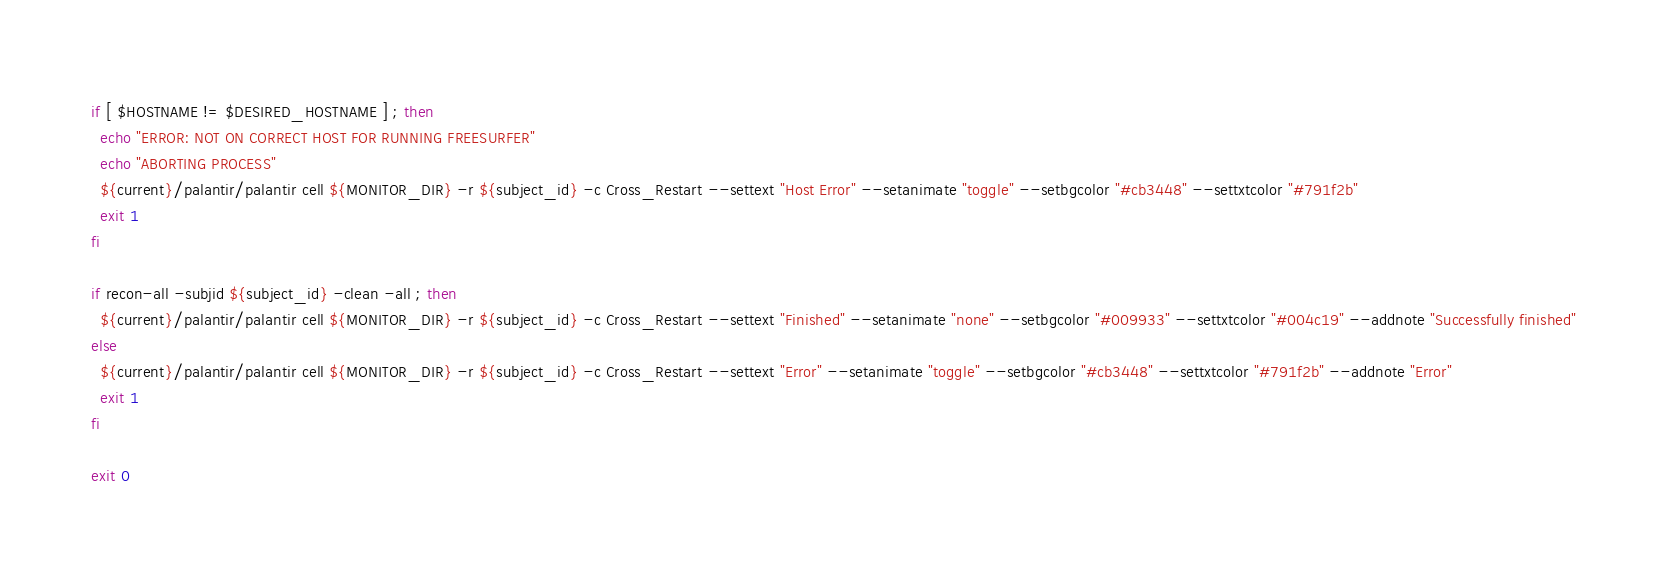<code> <loc_0><loc_0><loc_500><loc_500><_Bash_>
if [ $HOSTNAME != $DESIRED_HOSTNAME ] ; then
  echo "ERROR: NOT ON CORRECT HOST FOR RUNNING FREESURFER"
  echo "ABORTING PROCESS"
  ${current}/palantir/palantir cell ${MONITOR_DIR} -r ${subject_id} -c Cross_Restart --settext "Host Error" --setanimate "toggle" --setbgcolor "#cb3448" --settxtcolor "#791f2b"
  exit 1
fi

if recon-all -subjid ${subject_id} -clean -all ; then
  ${current}/palantir/palantir cell ${MONITOR_DIR} -r ${subject_id} -c Cross_Restart --settext "Finished" --setanimate "none" --setbgcolor "#009933" --settxtcolor "#004c19" --addnote "Successfully finished"
else
  ${current}/palantir/palantir cell ${MONITOR_DIR} -r ${subject_id} -c Cross_Restart --settext "Error" --setanimate "toggle" --setbgcolor "#cb3448" --settxtcolor "#791f2b" --addnote "Error"
  exit 1
fi

exit 0
</code> 